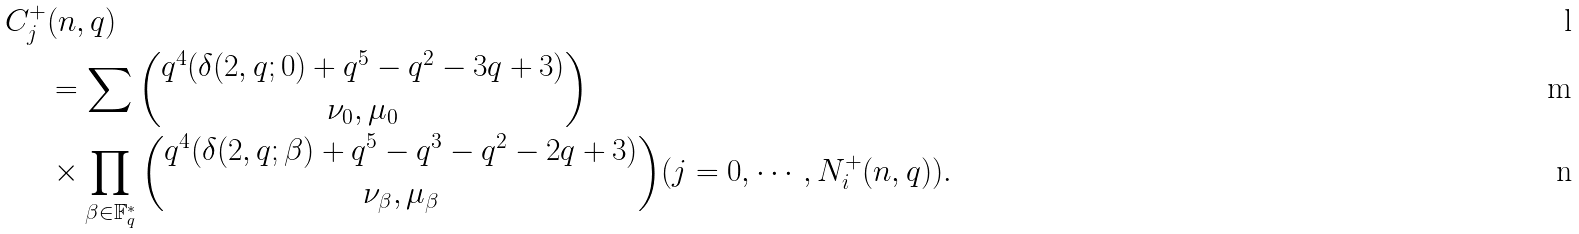Convert formula to latex. <formula><loc_0><loc_0><loc_500><loc_500>C _ { j } ^ { + } & ( n , q ) \\ & = \sum \binom { q ^ { 4 } ( \delta ( 2 , q ; 0 ) + q ^ { 5 } - q ^ { 2 } - 3 q + 3 ) } { \nu _ { 0 } , \mu _ { 0 } } \\ & \times \prod _ { \beta \in \mathbb { F } _ { q } ^ { * } } \binom { q ^ { 4 } ( \delta ( 2 , q ; \beta ) + q ^ { 5 } - q ^ { 3 } - q ^ { 2 } - 2 q + 3 ) } { \nu _ { \beta } , \mu _ { \beta } } ( j = 0 , \cdots , N _ { i } ^ { + } ( n , q ) ) .</formula> 